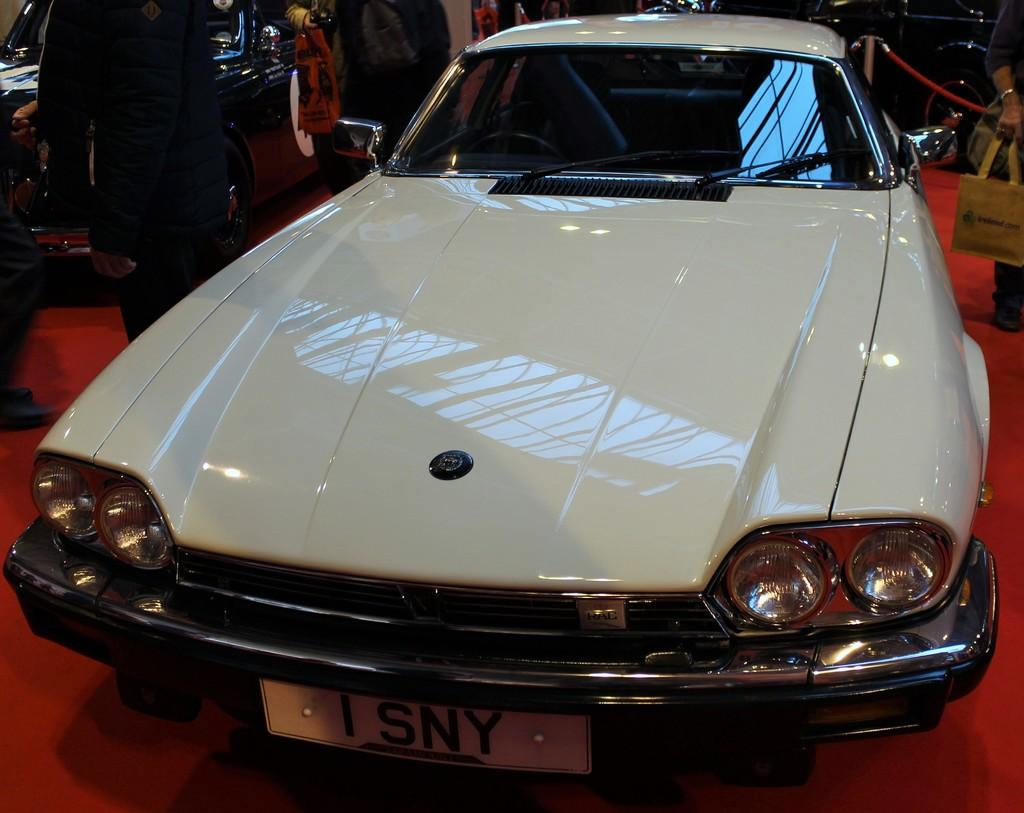What type of vehicle is in the image? There is a white car in the image. What is the car positioned on? The car is on a red carpet. Are there any people present in the image? Yes, there are people standing in the image. What can be seen in the background of the image? There is a red ribbon in the background of the image. What language is the chicken speaking in the image? There is no chicken present in the image, so it is not possible to determine what language it might be speaking. 